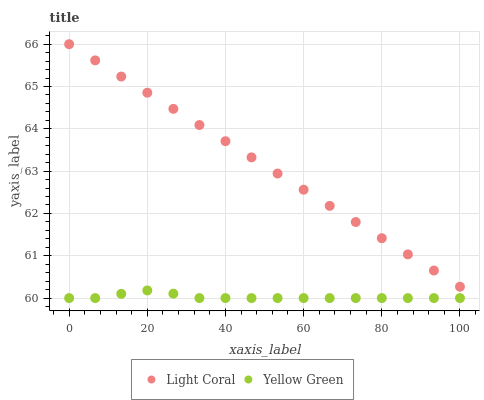Does Yellow Green have the minimum area under the curve?
Answer yes or no. Yes. Does Light Coral have the maximum area under the curve?
Answer yes or no. Yes. Does Yellow Green have the maximum area under the curve?
Answer yes or no. No. Is Light Coral the smoothest?
Answer yes or no. Yes. Is Yellow Green the roughest?
Answer yes or no. Yes. Is Yellow Green the smoothest?
Answer yes or no. No. Does Yellow Green have the lowest value?
Answer yes or no. Yes. Does Light Coral have the highest value?
Answer yes or no. Yes. Does Yellow Green have the highest value?
Answer yes or no. No. Is Yellow Green less than Light Coral?
Answer yes or no. Yes. Is Light Coral greater than Yellow Green?
Answer yes or no. Yes. Does Yellow Green intersect Light Coral?
Answer yes or no. No. 